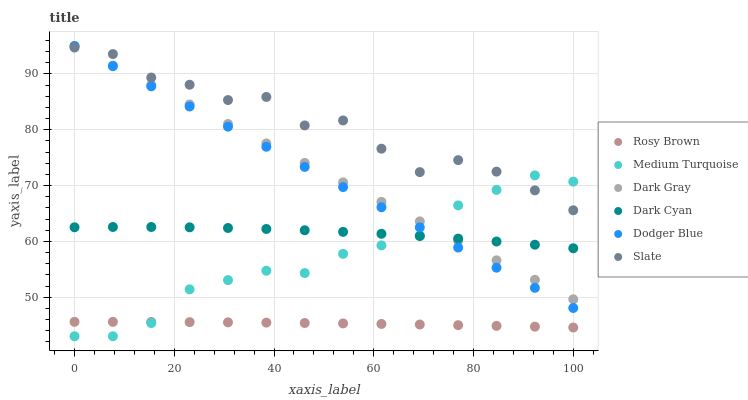Does Rosy Brown have the minimum area under the curve?
Answer yes or no. Yes. Does Slate have the maximum area under the curve?
Answer yes or no. Yes. Does Dark Gray have the minimum area under the curve?
Answer yes or no. No. Does Dark Gray have the maximum area under the curve?
Answer yes or no. No. Is Dark Gray the smoothest?
Answer yes or no. Yes. Is Slate the roughest?
Answer yes or no. Yes. Is Rosy Brown the smoothest?
Answer yes or no. No. Is Rosy Brown the roughest?
Answer yes or no. No. Does Medium Turquoise have the lowest value?
Answer yes or no. Yes. Does Rosy Brown have the lowest value?
Answer yes or no. No. Does Dodger Blue have the highest value?
Answer yes or no. Yes. Does Rosy Brown have the highest value?
Answer yes or no. No. Is Rosy Brown less than Dark Cyan?
Answer yes or no. Yes. Is Slate greater than Rosy Brown?
Answer yes or no. Yes. Does Slate intersect Medium Turquoise?
Answer yes or no. Yes. Is Slate less than Medium Turquoise?
Answer yes or no. No. Is Slate greater than Medium Turquoise?
Answer yes or no. No. Does Rosy Brown intersect Dark Cyan?
Answer yes or no. No. 